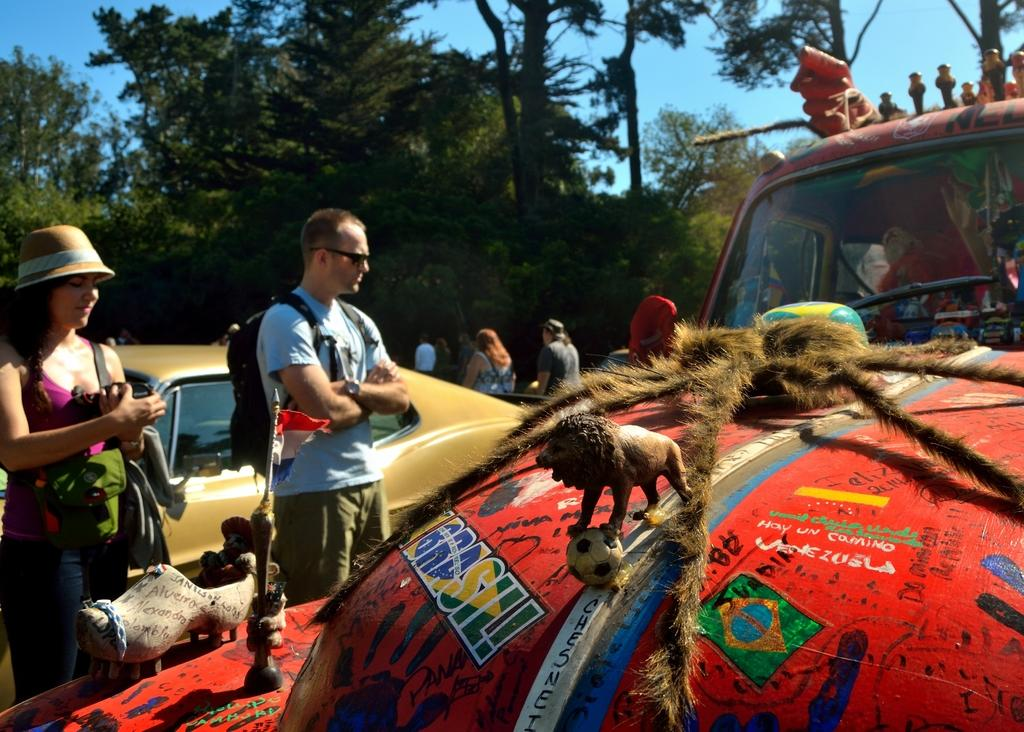Who or what can be seen in the image? There are people and vehicles in the image. What is visible in the background of the image? There are trees and the sky in the background of the image. What type of clouds can be seen in space in the image? There is no reference to clouds or space in the image; it features people, vehicles, trees, and the sky. 